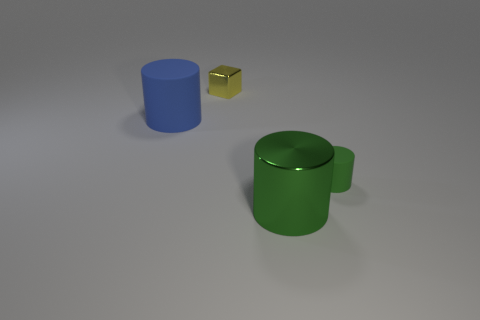Add 3 blue cylinders. How many objects exist? 7 Subtract all cylinders. How many objects are left? 1 Add 3 small matte things. How many small matte things are left? 4 Add 4 tiny blue metallic spheres. How many tiny blue metallic spheres exist? 4 Subtract 0 gray cylinders. How many objects are left? 4 Subtract all small green metallic cylinders. Subtract all yellow shiny cubes. How many objects are left? 3 